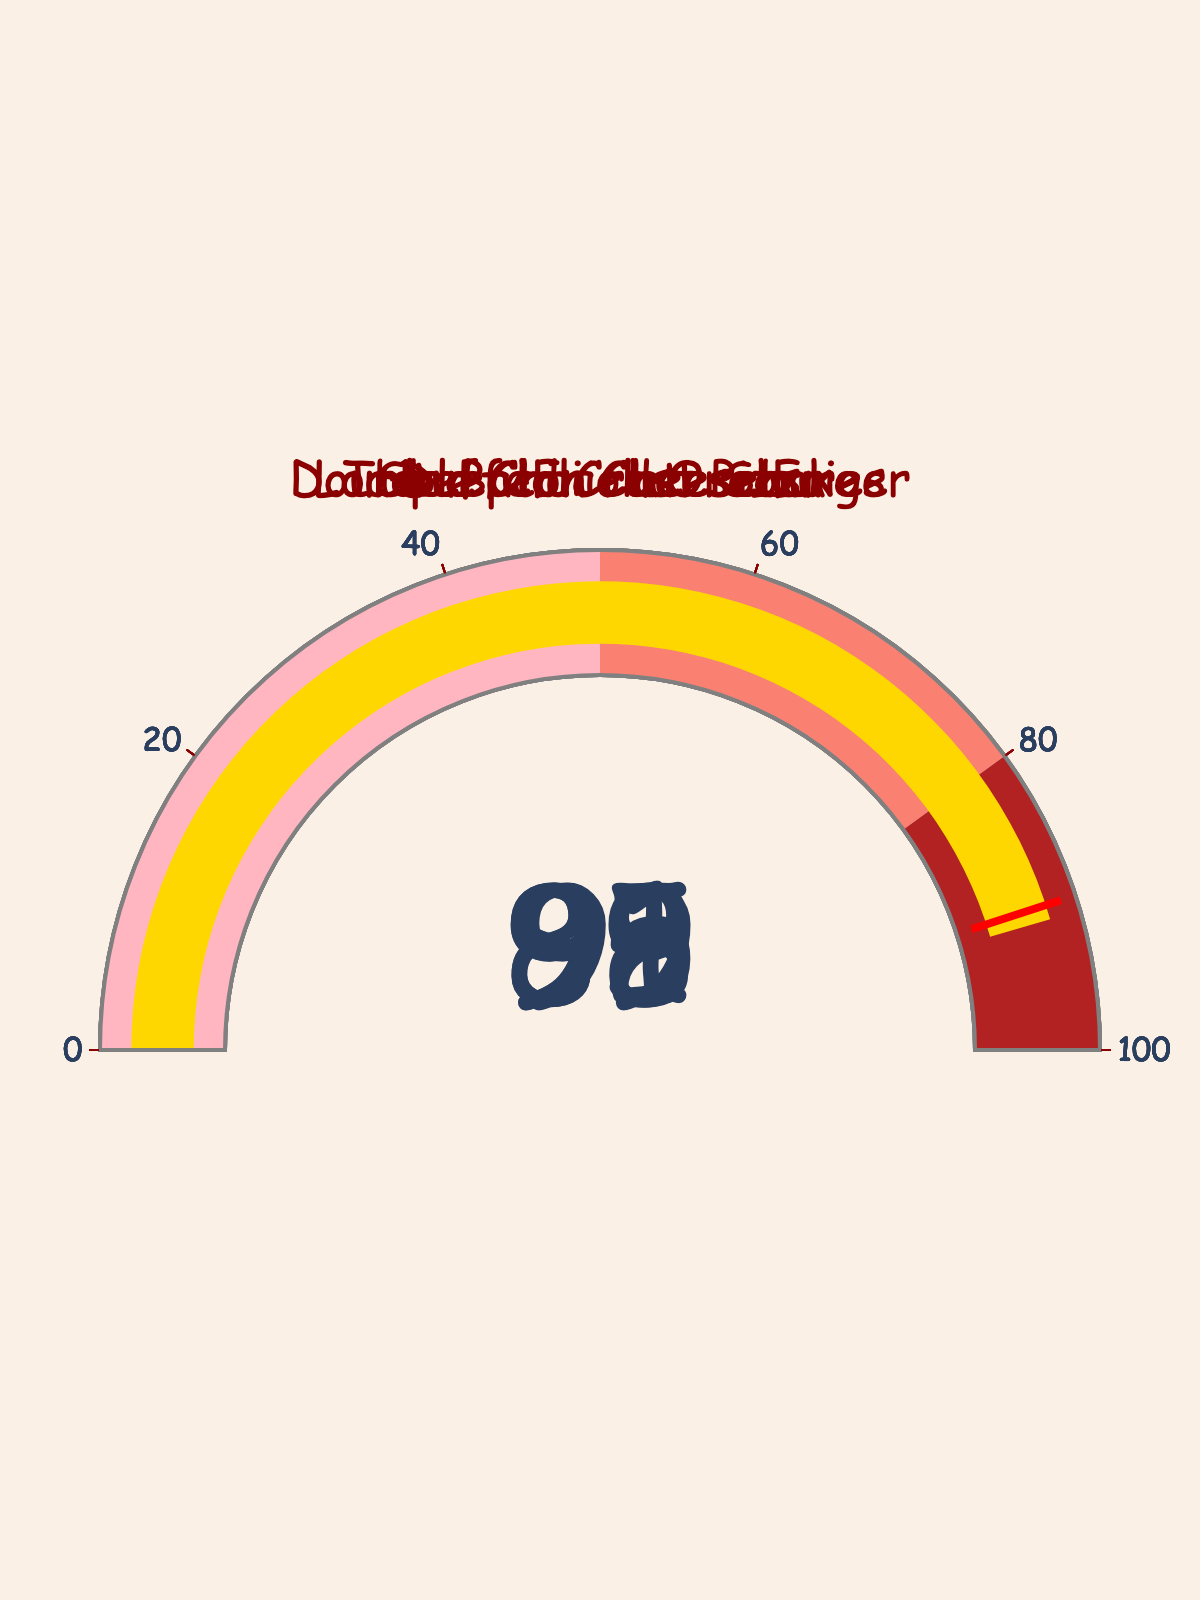What's the highest satisfaction rating displayed? The highest satisfaction rating is the maximum value among all the menu items' ratings. By examining the gauges, the Triple Chocolate Shake has the highest rating at 95.
Answer: 95 How many menu items have a satisfaction rating above 90? To determine this, count the number of gauges showing a value greater than 90. The Double Bacon Cheeseburger, Triple Chocolate Shake, and Stuffed Crust Pizza all have ratings above 90.
Answer: 3 Which menu item has the lowest satisfaction rating, and what is it? Compare the values on each gauge to find the lowest satisfaction rating. The Loaded Chili Cheese Fries have the lowest satisfaction rating at 88.
Answer: Loaded Chili Cheese Fries, 88 If we want to calculate the average satisfaction rating, what would it be? The average is calculated by summing all the satisfaction ratings and dividing by the total number of items. The sum is 92 + 88 + 95 + 89 + 91 = 455. Divide by 5 to get the average.
Answer: 91 Which two menu items have satisfaction ratings that differ by exactly 3 points? By inspecting the differences between the ratings: Double Bacon Cheeseburger (92) and Stuffed Crust Pizza (91) differ by 1 point; Loaded Chili Cheese Fries (88) and Deep-Fried Oreos (89) differ by 1 point; Triple Chocolate Shake (95) and Deep-Fried Oreos (89) differ by 6 points. Hence, no two items differ by exactly 3 points.
Answer: None Which menu item has a satisfaction rating closest to the average rating? First compute the average rating: (92 + 88 + 95 + 89 + 91) / 5 = 91. Then check each item's rating from the gauges for closeness to 91: Double Bacon Cheeseburger (92) is 1 away, Loaded Chili Cheese Fries (88) is 3 away, Triple Chocolate Shake (95) is 4 away, Deep-Fried Oreos (89) is 2 away, and Stuffed Crust Pizza is equal to the average at 91.
Answer: Stuffed Crust Pizza Which menu item has a satisfaction rating above 85 and below 90? Check each gauge and identify items with values greater than 85 and less than 90: Loaded Chili Cheese Fries (88) and Deep-Fried Oreos (89) fit this criterion.
Answer: Loaded Chili Cheese Fries and Deep-Fried Oreos Which menu items are within the 'firebrick' color range on the gauge? The 'firebrick' color range on the gauge is between 80 and 100. Identify items with satisfaction ratings within this range: All five items (Double Bacon Cheeseburger, Loaded Chili Cheese Fries, Triple Chocolate Shake, Deep-Fried Oreos, Stuffed Crust Pizza) fall within this range.
Answer: All items 